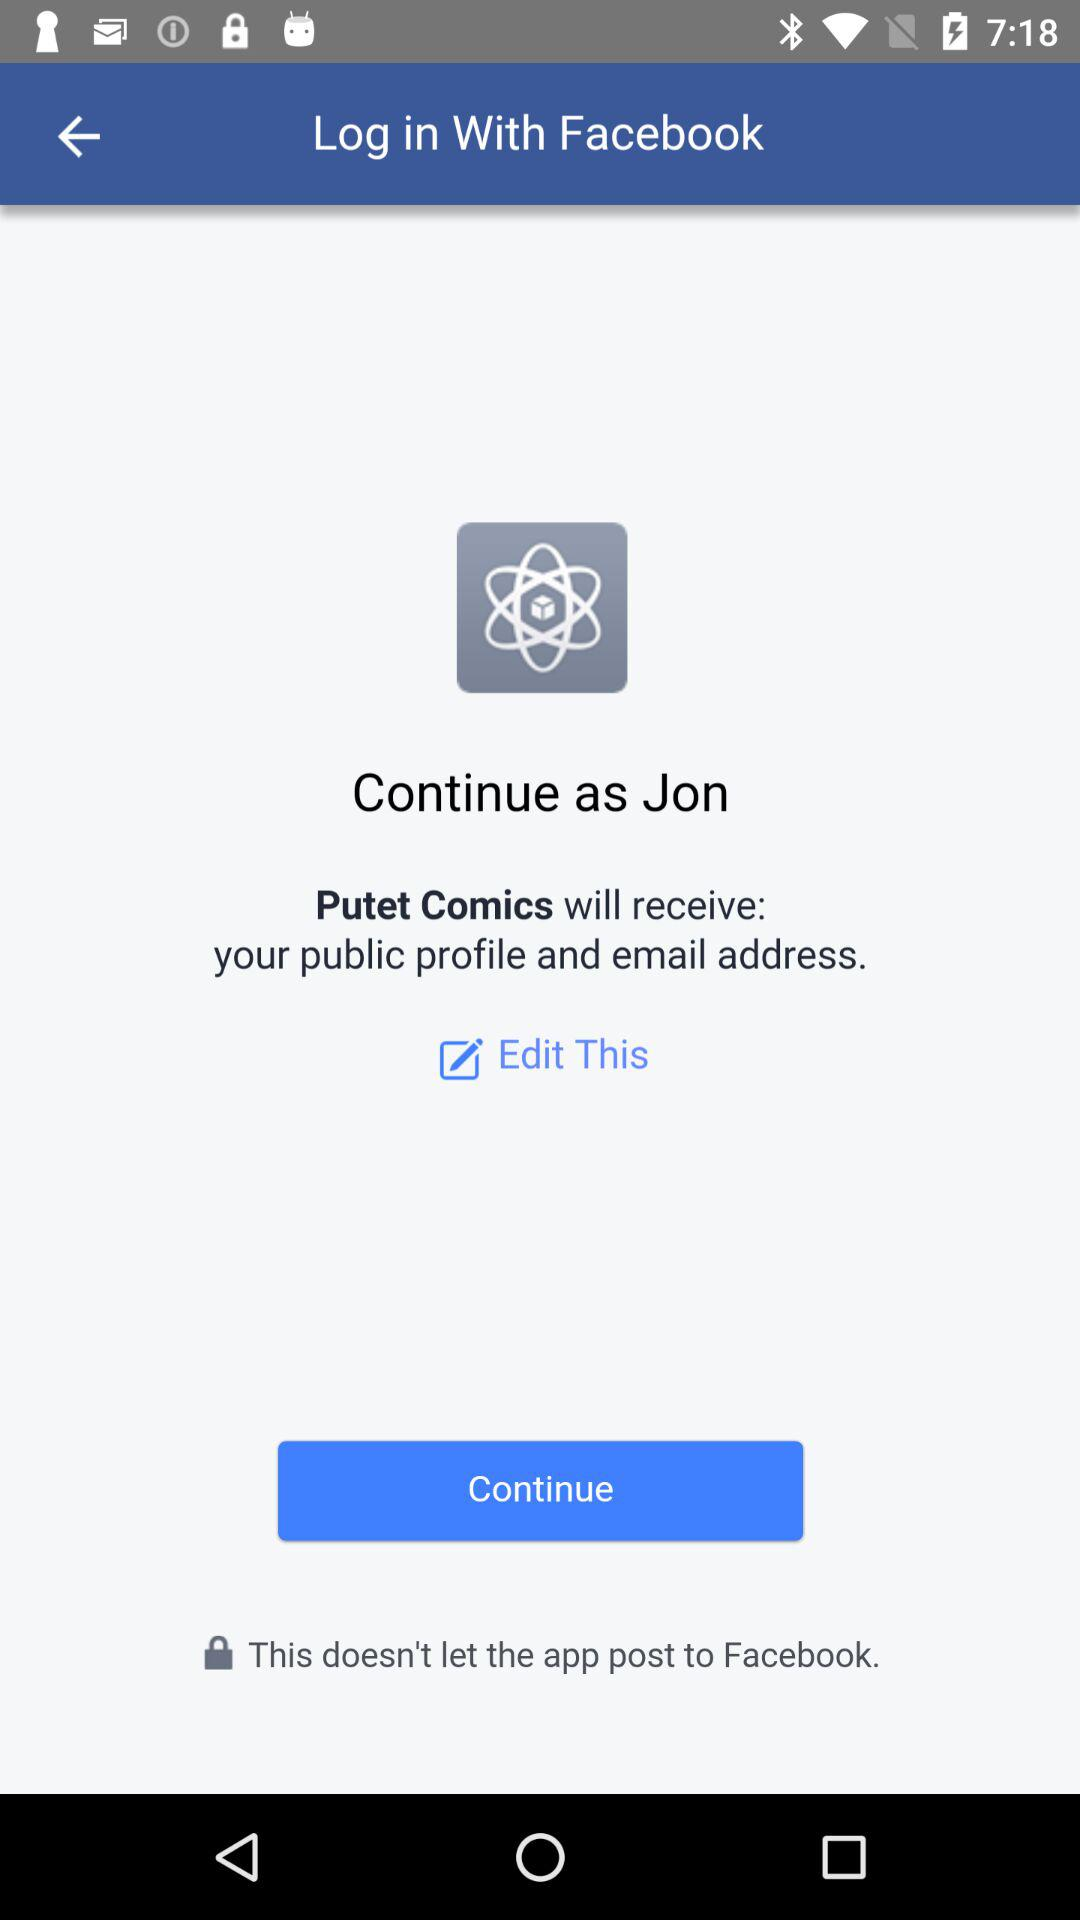What application is asking for the permission? The application that is asking for the permission is "Putet Comics". 